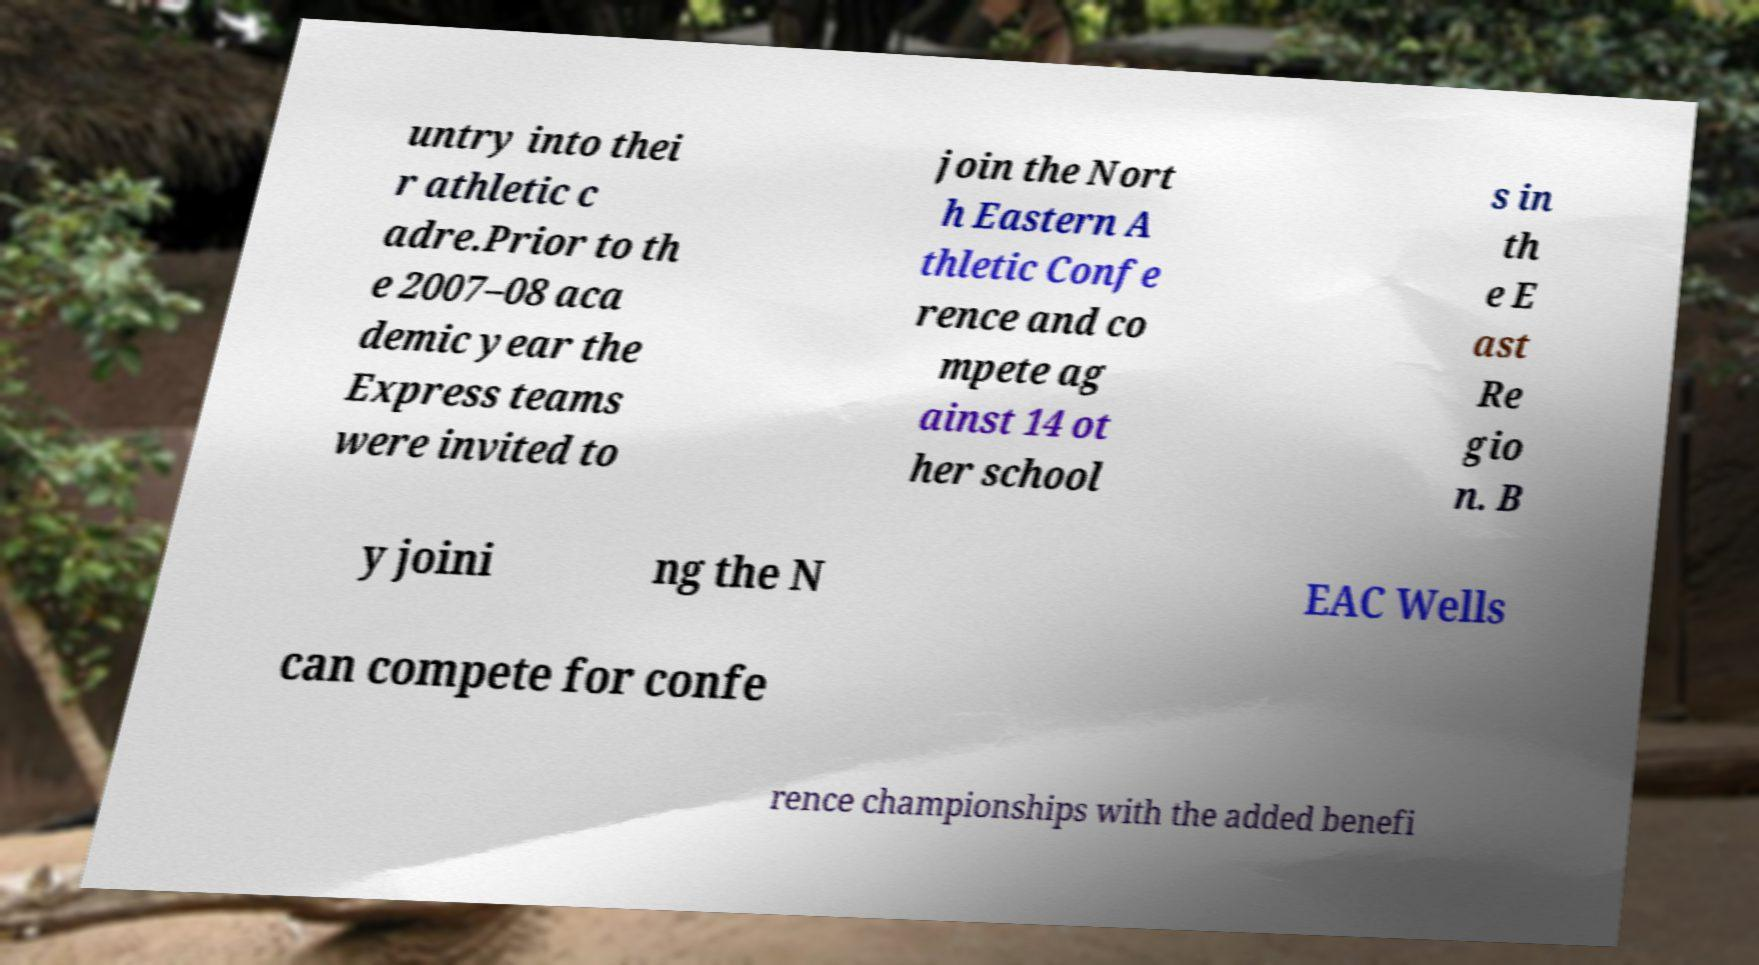I need the written content from this picture converted into text. Can you do that? untry into thei r athletic c adre.Prior to th e 2007–08 aca demic year the Express teams were invited to join the Nort h Eastern A thletic Confe rence and co mpete ag ainst 14 ot her school s in th e E ast Re gio n. B y joini ng the N EAC Wells can compete for confe rence championships with the added benefi 